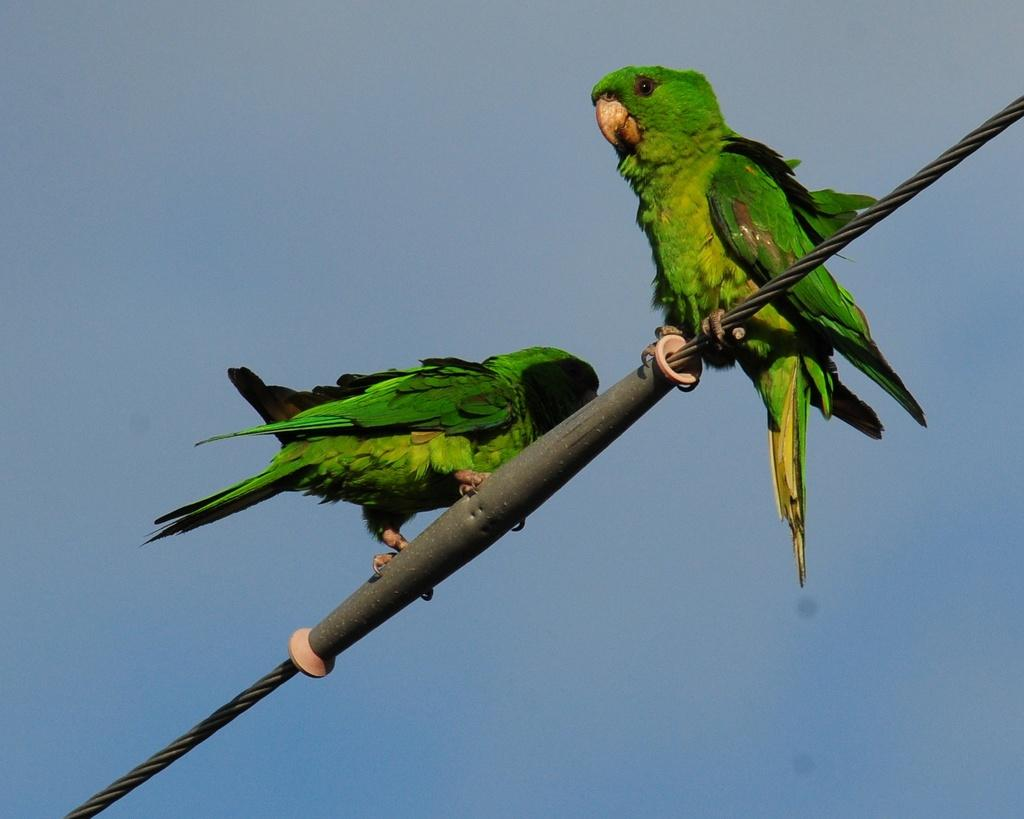What animals can be seen in the image? There are birds on a wire in the image. What is visible in the background of the image? The sky is visible in the background of the image. How many sparks can be seen coming from the bridge in the image? There is no bridge present in the image, and therefore no sparks can be observed. 